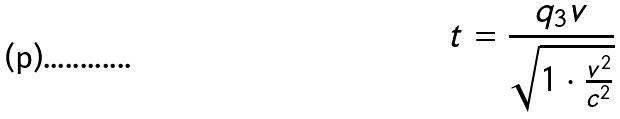<formula> <loc_0><loc_0><loc_500><loc_500>t = \frac { q _ { 3 } v } { \sqrt { 1 \cdot \frac { v ^ { 2 } } { c ^ { 2 } } } }</formula> 